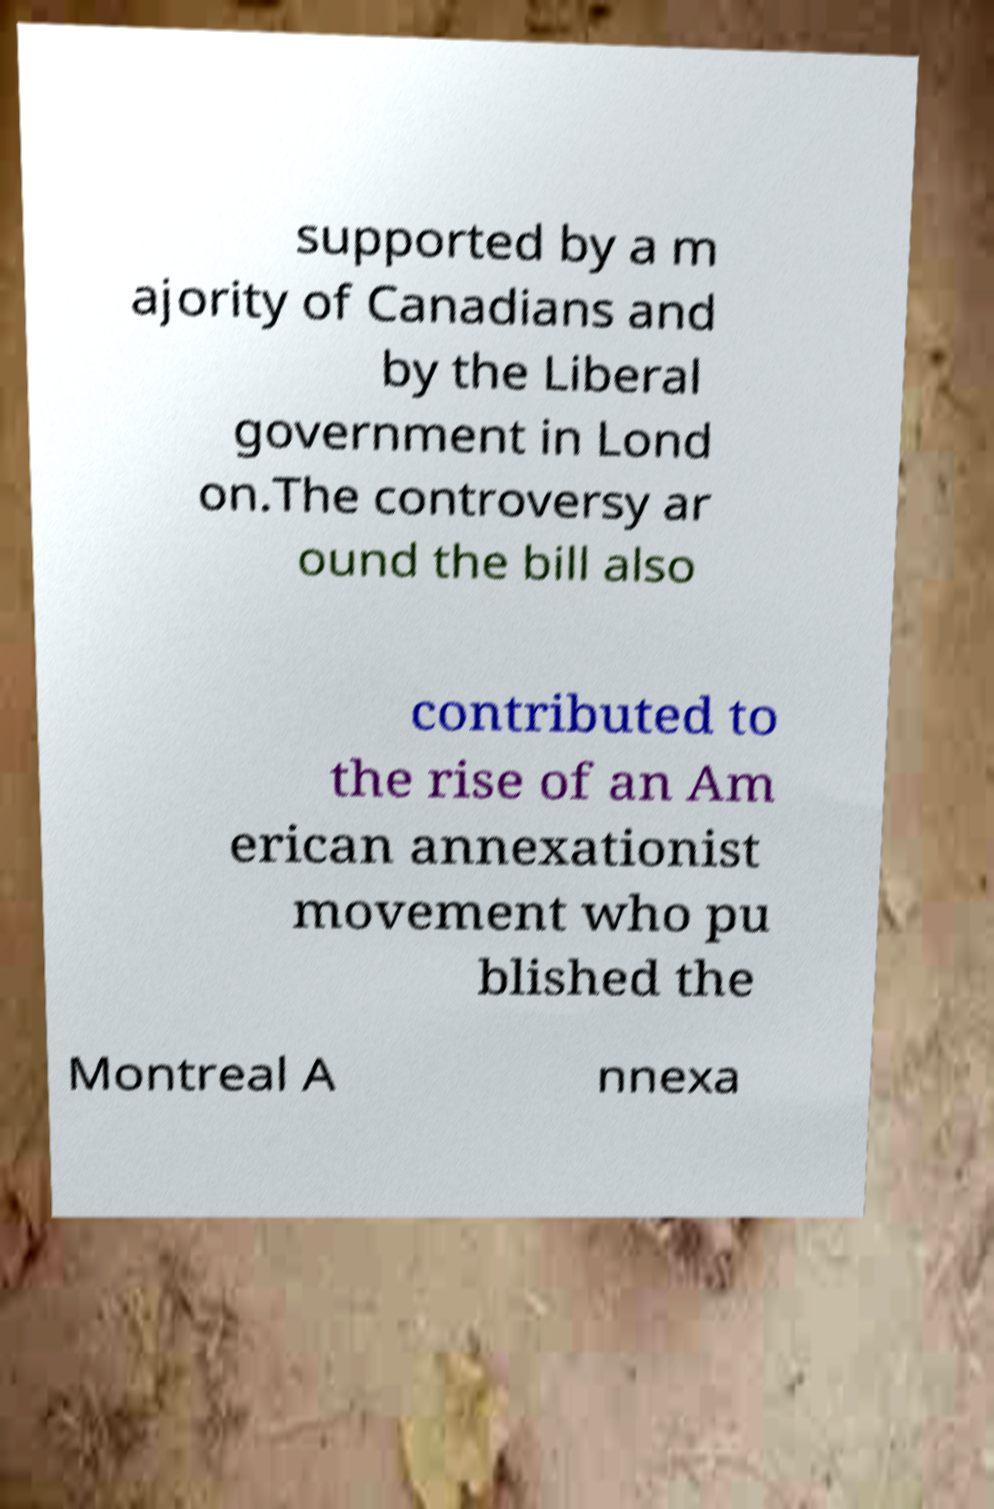Could you extract and type out the text from this image? supported by a m ajority of Canadians and by the Liberal government in Lond on.The controversy ar ound the bill also contributed to the rise of an Am erican annexationist movement who pu blished the Montreal A nnexa 